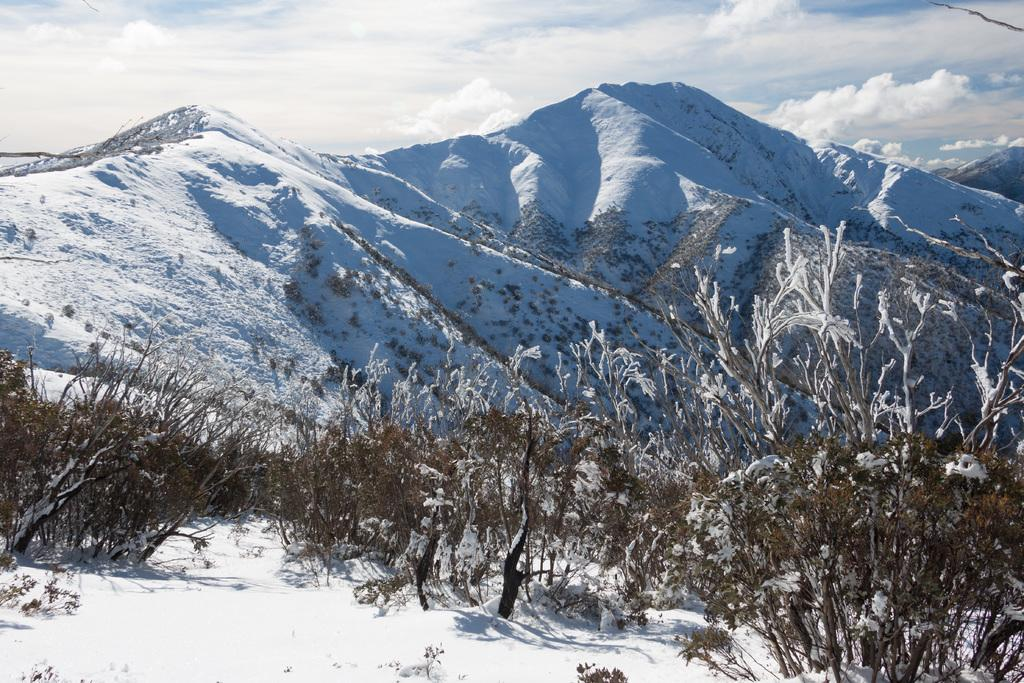What type of living organisms can be seen in the image? Plants can be seen in the image. What type of natural landscape is visible in the image? There are snowy hills in the image. What is the condition of the sky in the image? The sky is cloudy in the image. Can you see a beetle building a nest in the image? There is no beetle or nest present in the image. How many visitors can be seen in the image? There are no visitors visible in the image. 